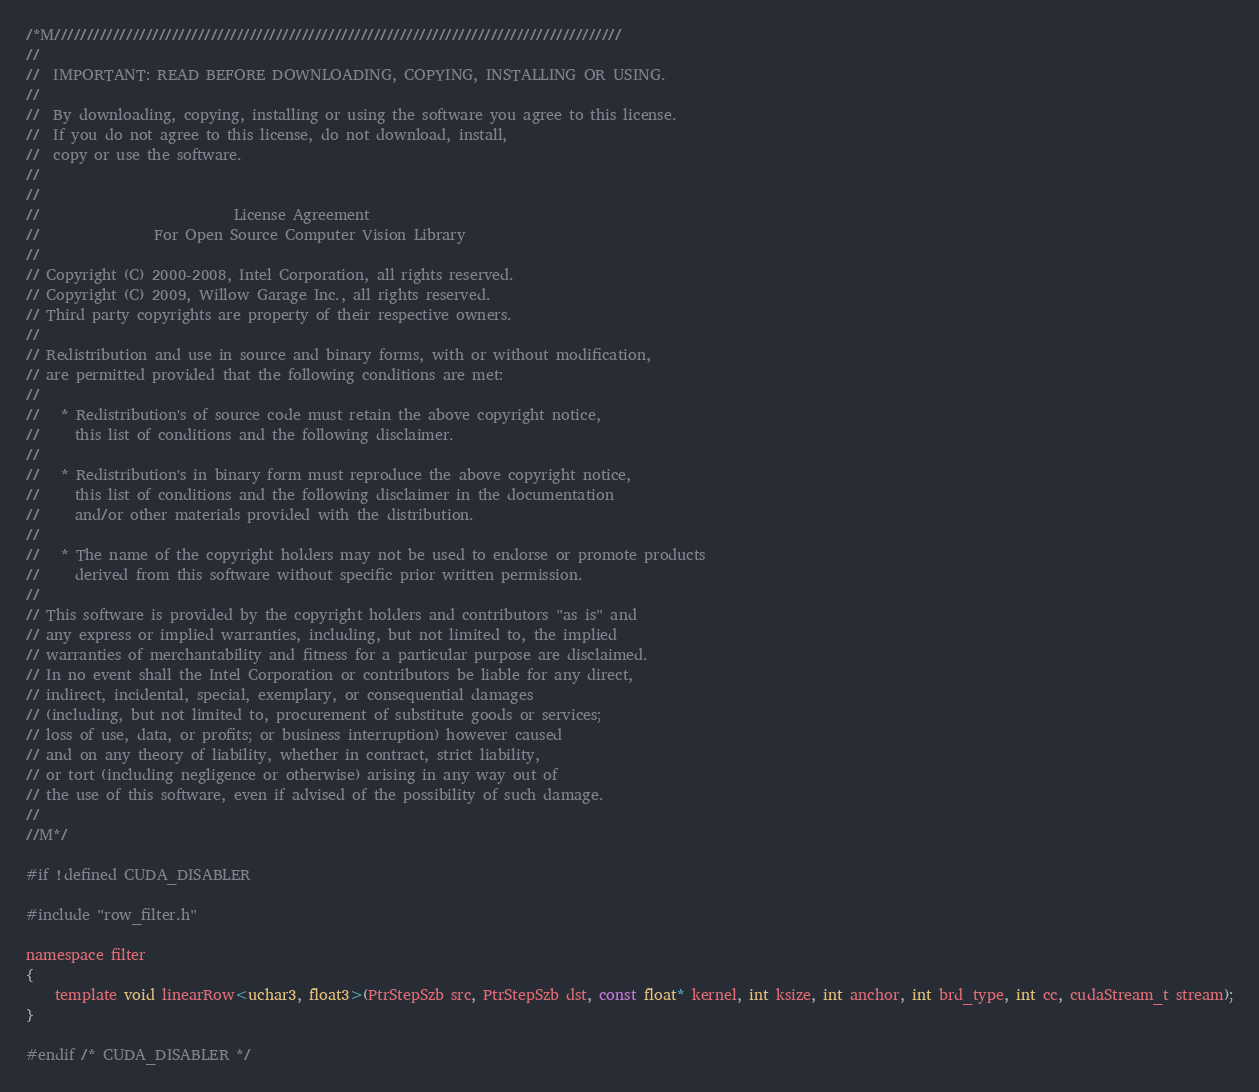<code> <loc_0><loc_0><loc_500><loc_500><_Cuda_>/*M///////////////////////////////////////////////////////////////////////////////////////
//
//  IMPORTANT: READ BEFORE DOWNLOADING, COPYING, INSTALLING OR USING.
//
//  By downloading, copying, installing or using the software you agree to this license.
//  If you do not agree to this license, do not download, install,
//  copy or use the software.
//
//
//                           License Agreement
//                For Open Source Computer Vision Library
//
// Copyright (C) 2000-2008, Intel Corporation, all rights reserved.
// Copyright (C) 2009, Willow Garage Inc., all rights reserved.
// Third party copyrights are property of their respective owners.
//
// Redistribution and use in source and binary forms, with or without modification,
// are permitted provided that the following conditions are met:
//
//   * Redistribution's of source code must retain the above copyright notice,
//     this list of conditions and the following disclaimer.
//
//   * Redistribution's in binary form must reproduce the above copyright notice,
//     this list of conditions and the following disclaimer in the documentation
//     and/or other materials provided with the distribution.
//
//   * The name of the copyright holders may not be used to endorse or promote products
//     derived from this software without specific prior written permission.
//
// This software is provided by the copyright holders and contributors "as is" and
// any express or implied warranties, including, but not limited to, the implied
// warranties of merchantability and fitness for a particular purpose are disclaimed.
// In no event shall the Intel Corporation or contributors be liable for any direct,
// indirect, incidental, special, exemplary, or consequential damages
// (including, but not limited to, procurement of substitute goods or services;
// loss of use, data, or profits; or business interruption) however caused
// and on any theory of liability, whether in contract, strict liability,
// or tort (including negligence or otherwise) arising in any way out of
// the use of this software, even if advised of the possibility of such damage.
//
//M*/

#if !defined CUDA_DISABLER

#include "row_filter.h"

namespace filter
{
    template void linearRow<uchar3, float3>(PtrStepSzb src, PtrStepSzb dst, const float* kernel, int ksize, int anchor, int brd_type, int cc, cudaStream_t stream);
}

#endif /* CUDA_DISABLER */
</code> 